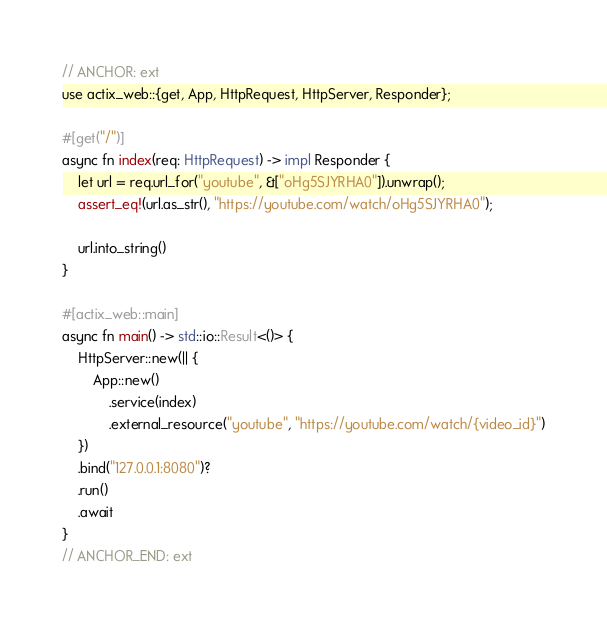<code> <loc_0><loc_0><loc_500><loc_500><_Rust_>// ANCHOR: ext
use actix_web::{get, App, HttpRequest, HttpServer, Responder};

#[get("/")]
async fn index(req: HttpRequest) -> impl Responder {
    let url = req.url_for("youtube", &["oHg5SJYRHA0"]).unwrap();
    assert_eq!(url.as_str(), "https://youtube.com/watch/oHg5SJYRHA0");

    url.into_string()
}

#[actix_web::main]
async fn main() -> std::io::Result<()> {
    HttpServer::new(|| {
        App::new()
            .service(index)
            .external_resource("youtube", "https://youtube.com/watch/{video_id}")
    })
    .bind("127.0.0.1:8080")?
    .run()
    .await
}
// ANCHOR_END: ext
</code> 